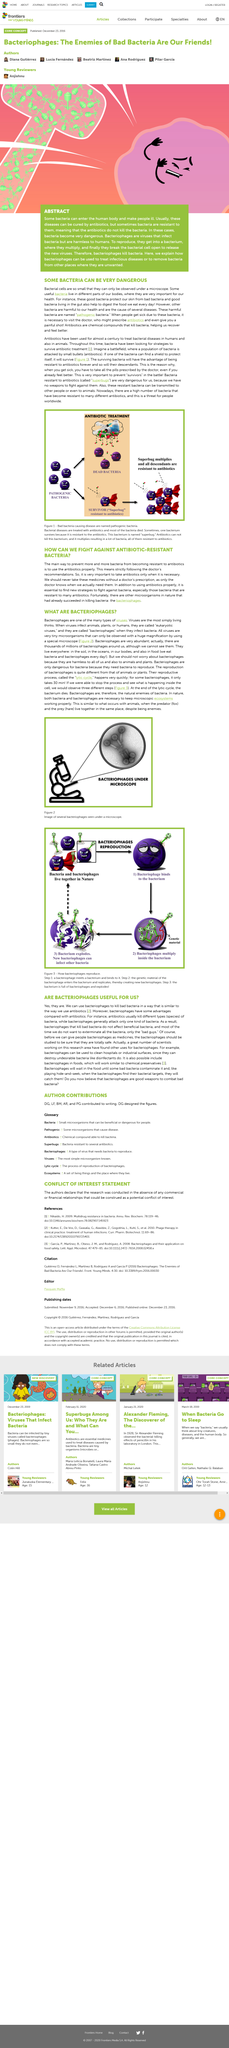List a handful of essential elements in this visual. The photograph depicts the potential entry points for bacteria to infiltrate the human body. It is imperative that we never take antibiotics without a doctor's prescription, as this can lead to serious health consequences. Pathogenic bacteria are dangerous bacteria that can cause harm to living organisms, including humans. Bacteriophages, also known as phages, are viruses that can effectively eliminate bacteria. These viruses are particularly effective in destroying harmful bacteria and can be used as a natural and safe method for killing bacteria. Bacteriophages, microorganisms found in nature, are successful in killing bacteria and are therefore considered a natural defense against bacterial infections. 